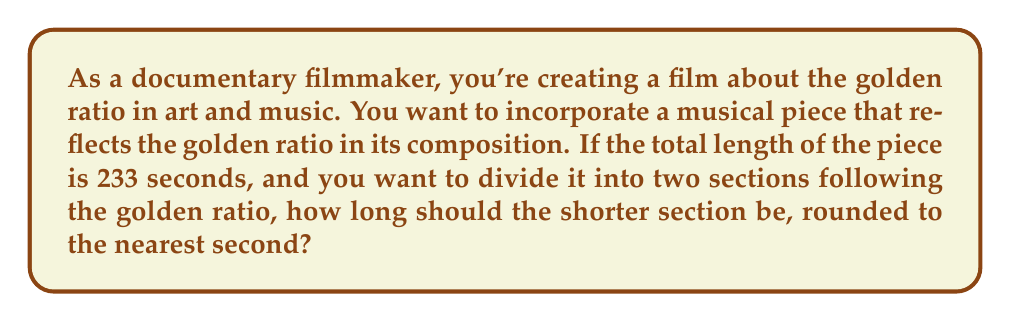What is the answer to this math problem? Let's approach this step-by-step:

1) The golden ratio, often denoted by $\phi$ (phi), is approximately equal to 1.618033988749895...

2) In a golden ratio division, the ratio of the longer part to the shorter part is equal to the ratio of the whole to the longer part. Mathematically, this can be expressed as:

   $$\frac{a+b}{a} = \frac{a}{b} = \phi$$

   where $a$ is the longer part and $b$ is the shorter part.

3) We know that the total length of the piece is 233 seconds. Let $x$ be the length of the shorter section. Then, $233-x$ is the length of the longer section.

4) We can set up the equation:

   $$\frac{233}{233-x} = \frac{233-x}{x} = \phi$$

5) We can simplify this to:

   $$\frac{233-x}{x} = \phi$$

6) Cross-multiplying:

   $$233 - x = \phi x$$

7) Rearranging:

   $$233 = x + \phi x = x(1 + \phi)$$

8) Solving for $x$:

   $$x = \frac{233}{1 + \phi}$$

9) We know that $\phi = \frac{1 + \sqrt{5}}{2}$, so:

   $$x = \frac{233}{1 + \frac{1 + \sqrt{5}}{2}} = \frac{233}{\frac{3 + \sqrt{5}}{2}} = \frac{466}{3 + \sqrt{5}} \approx 88.9746...$$

10) Rounding to the nearest second:

    $$x \approx 89$$

Therefore, the shorter section should be 89 seconds long.
Answer: 89 seconds 